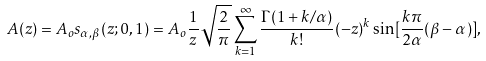<formula> <loc_0><loc_0><loc_500><loc_500>A ( z ) = A _ { o } s _ { \alpha , \beta } ( z ; 0 , 1 ) = A _ { o } \frac { 1 } { z } \sqrt { \frac { 2 } { \pi } } \sum _ { k = 1 } ^ { \infty } \frac { \Gamma ( 1 + k / \alpha ) } { k ! } ( - z ) ^ { k } \sin [ \frac { k \pi } { 2 \alpha } ( \beta - \alpha ) ] ,</formula> 